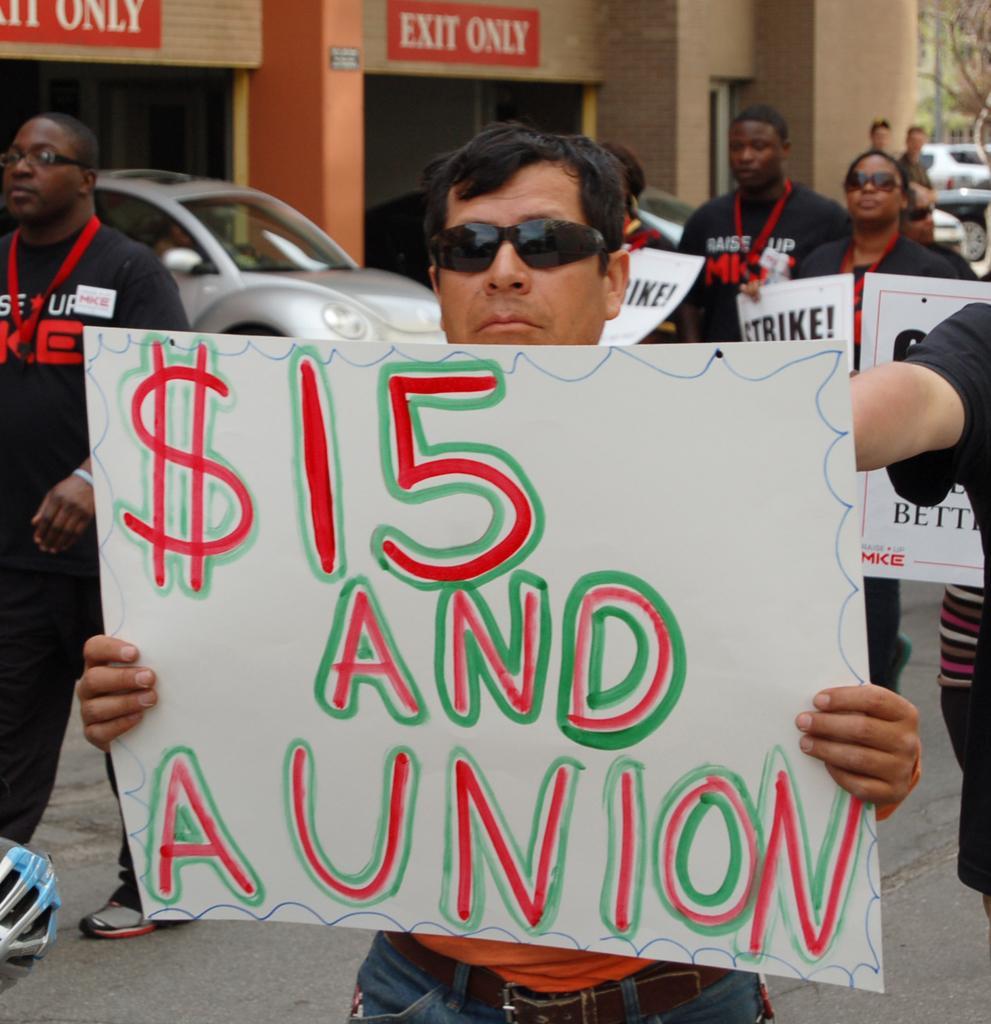Describe this image in one or two sentences. In this image I can see a man is standing by holding the placard in his hand. On the left side there is a vehicle under the building. 